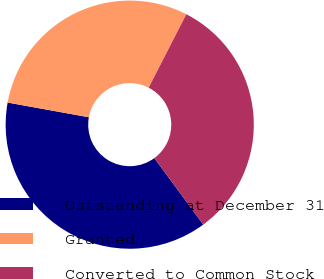Convert chart. <chart><loc_0><loc_0><loc_500><loc_500><pie_chart><fcel>Outstanding at December 31<fcel>Granted<fcel>Converted to Common Stock<nl><fcel>37.95%<fcel>29.69%<fcel>32.36%<nl></chart> 